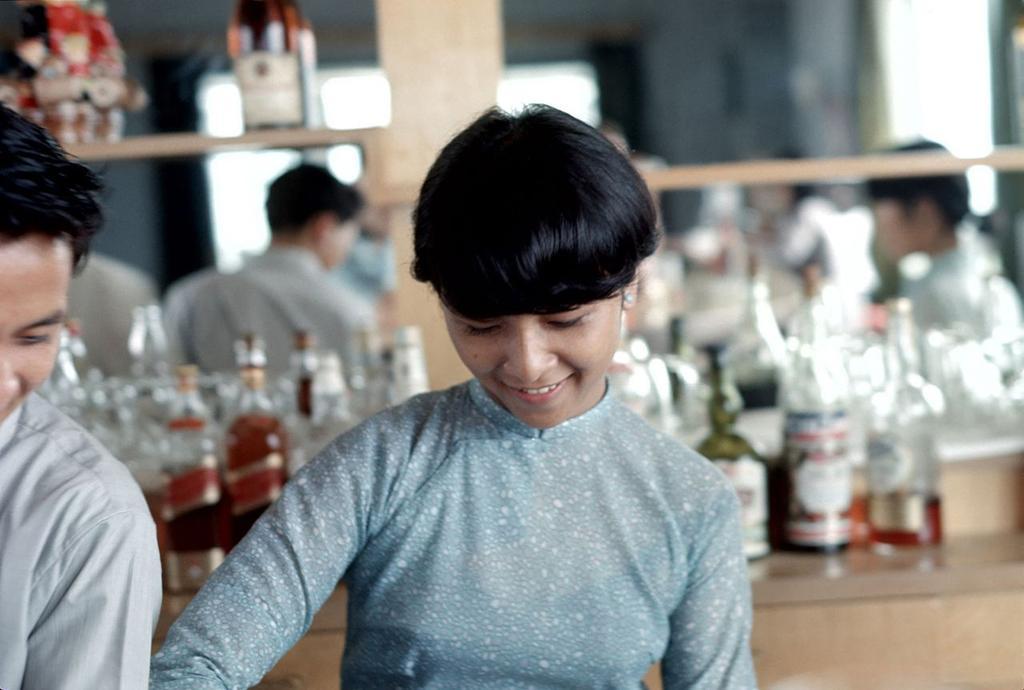How would you summarize this image in a sentence or two? In this picture there is a woman wearing a blue top. Beside her there is another man in white shirt. Behind them there are bottles placed on the table. In the background there are people, wall etc. 